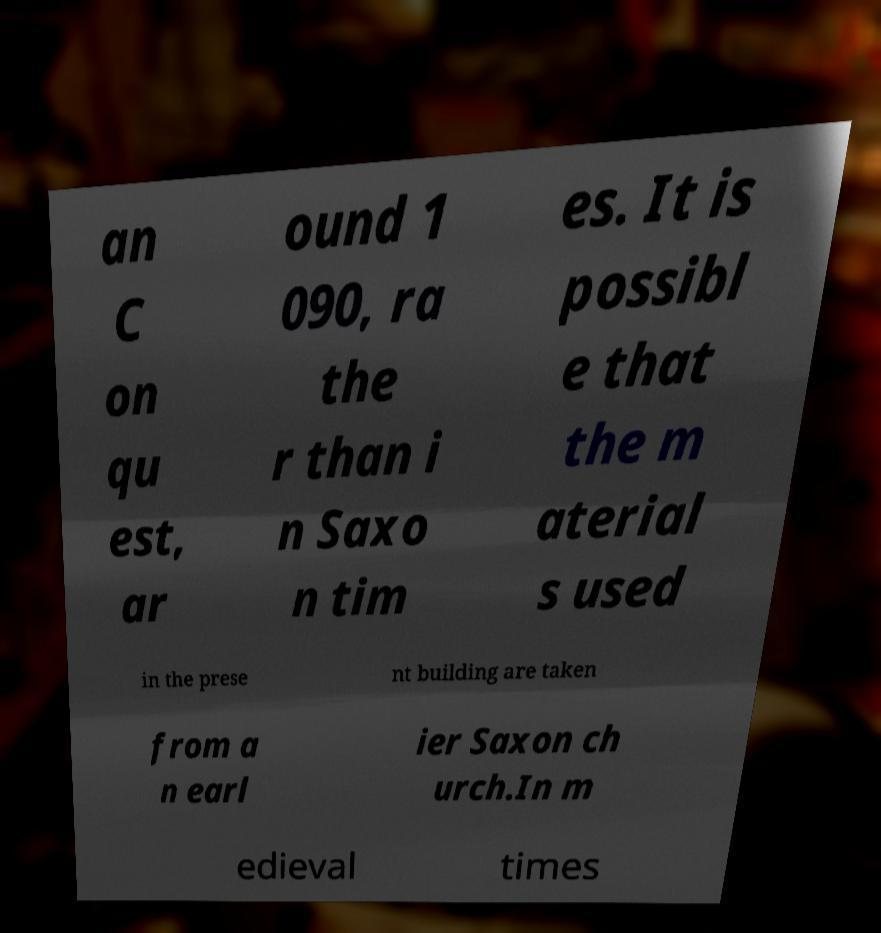What messages or text are displayed in this image? I need them in a readable, typed format. an C on qu est, ar ound 1 090, ra the r than i n Saxo n tim es. It is possibl e that the m aterial s used in the prese nt building are taken from a n earl ier Saxon ch urch.In m edieval times 